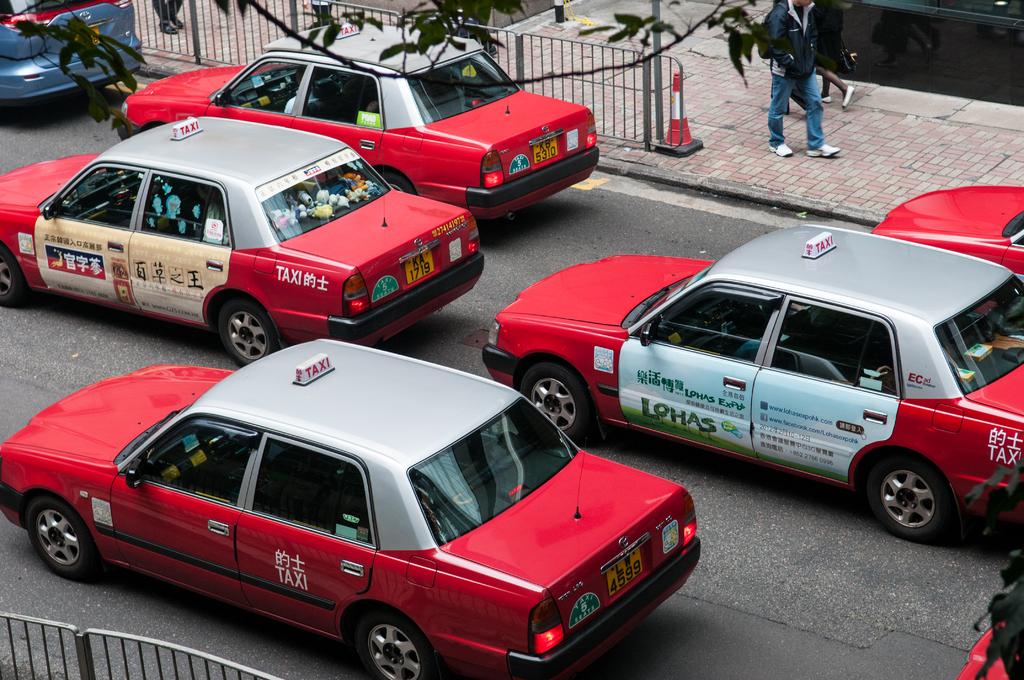What country are these taxis in?
Make the answer very short. Unanswerable. What does the tag say at the bottom?
Give a very brief answer. Unanswerable. 